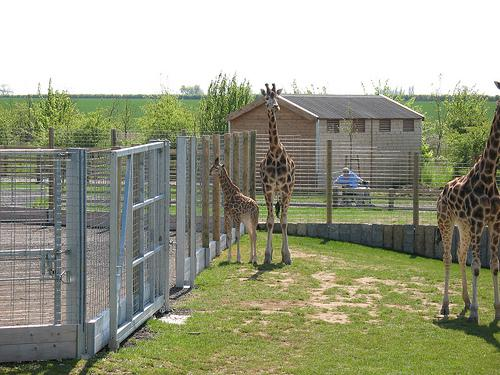Question: what is in the background?
Choices:
A. A car.
B. A truck.
C. A building.
D. A skyscraper.
Answer with the letter. Answer: C Question: how many giraffes are there?
Choices:
A. Two.
B. Three.
C. Four.
D. Five.
Answer with the letter. Answer: B Question: what are the giraffes in?
Choices:
A. A pen.
B. A building.
C. A pond.
D. A forest.
Answer with the letter. Answer: A Question: what are the giraffes standing on?
Choices:
A. Dirt.
B. Sand.
C. Brick.
D. Grass.
Answer with the letter. Answer: D Question: who is sitting on the bench?
Choices:
A. A woman.
B. A child.
C. An animal.
D. A man.
Answer with the letter. Answer: D 